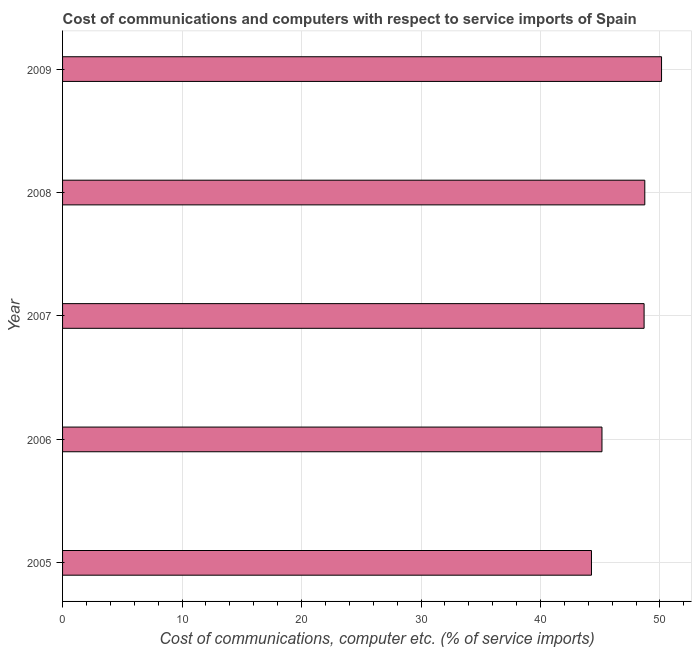What is the title of the graph?
Your answer should be compact. Cost of communications and computers with respect to service imports of Spain. What is the label or title of the X-axis?
Offer a very short reply. Cost of communications, computer etc. (% of service imports). What is the cost of communications and computer in 2007?
Offer a terse response. 48.67. Across all years, what is the maximum cost of communications and computer?
Offer a very short reply. 50.13. Across all years, what is the minimum cost of communications and computer?
Offer a very short reply. 44.27. In which year was the cost of communications and computer maximum?
Provide a short and direct response. 2009. In which year was the cost of communications and computer minimum?
Offer a very short reply. 2005. What is the sum of the cost of communications and computer?
Your answer should be compact. 236.94. What is the difference between the cost of communications and computer in 2005 and 2006?
Keep it short and to the point. -0.88. What is the average cost of communications and computer per year?
Offer a very short reply. 47.39. What is the median cost of communications and computer?
Your answer should be compact. 48.67. What is the difference between the highest and the second highest cost of communications and computer?
Keep it short and to the point. 1.4. Is the sum of the cost of communications and computer in 2005 and 2009 greater than the maximum cost of communications and computer across all years?
Offer a very short reply. Yes. What is the difference between the highest and the lowest cost of communications and computer?
Keep it short and to the point. 5.86. In how many years, is the cost of communications and computer greater than the average cost of communications and computer taken over all years?
Your answer should be very brief. 3. How many bars are there?
Ensure brevity in your answer.  5. Are all the bars in the graph horizontal?
Offer a very short reply. Yes. How many years are there in the graph?
Provide a succinct answer. 5. What is the difference between two consecutive major ticks on the X-axis?
Your answer should be very brief. 10. Are the values on the major ticks of X-axis written in scientific E-notation?
Offer a terse response. No. What is the Cost of communications, computer etc. (% of service imports) of 2005?
Offer a very short reply. 44.27. What is the Cost of communications, computer etc. (% of service imports) in 2006?
Give a very brief answer. 45.14. What is the Cost of communications, computer etc. (% of service imports) of 2007?
Provide a succinct answer. 48.67. What is the Cost of communications, computer etc. (% of service imports) in 2008?
Offer a very short reply. 48.73. What is the Cost of communications, computer etc. (% of service imports) of 2009?
Ensure brevity in your answer.  50.13. What is the difference between the Cost of communications, computer etc. (% of service imports) in 2005 and 2006?
Your answer should be very brief. -0.88. What is the difference between the Cost of communications, computer etc. (% of service imports) in 2005 and 2007?
Your answer should be very brief. -4.4. What is the difference between the Cost of communications, computer etc. (% of service imports) in 2005 and 2008?
Give a very brief answer. -4.46. What is the difference between the Cost of communications, computer etc. (% of service imports) in 2005 and 2009?
Your response must be concise. -5.86. What is the difference between the Cost of communications, computer etc. (% of service imports) in 2006 and 2007?
Your response must be concise. -3.53. What is the difference between the Cost of communications, computer etc. (% of service imports) in 2006 and 2008?
Keep it short and to the point. -3.58. What is the difference between the Cost of communications, computer etc. (% of service imports) in 2006 and 2009?
Offer a terse response. -4.99. What is the difference between the Cost of communications, computer etc. (% of service imports) in 2007 and 2008?
Your response must be concise. -0.06. What is the difference between the Cost of communications, computer etc. (% of service imports) in 2007 and 2009?
Provide a short and direct response. -1.46. What is the difference between the Cost of communications, computer etc. (% of service imports) in 2008 and 2009?
Keep it short and to the point. -1.4. What is the ratio of the Cost of communications, computer etc. (% of service imports) in 2005 to that in 2006?
Offer a very short reply. 0.98. What is the ratio of the Cost of communications, computer etc. (% of service imports) in 2005 to that in 2007?
Keep it short and to the point. 0.91. What is the ratio of the Cost of communications, computer etc. (% of service imports) in 2005 to that in 2008?
Make the answer very short. 0.91. What is the ratio of the Cost of communications, computer etc. (% of service imports) in 2005 to that in 2009?
Your response must be concise. 0.88. What is the ratio of the Cost of communications, computer etc. (% of service imports) in 2006 to that in 2007?
Ensure brevity in your answer.  0.93. What is the ratio of the Cost of communications, computer etc. (% of service imports) in 2006 to that in 2008?
Keep it short and to the point. 0.93. What is the ratio of the Cost of communications, computer etc. (% of service imports) in 2006 to that in 2009?
Your answer should be very brief. 0.9. What is the ratio of the Cost of communications, computer etc. (% of service imports) in 2007 to that in 2008?
Your answer should be very brief. 1. 